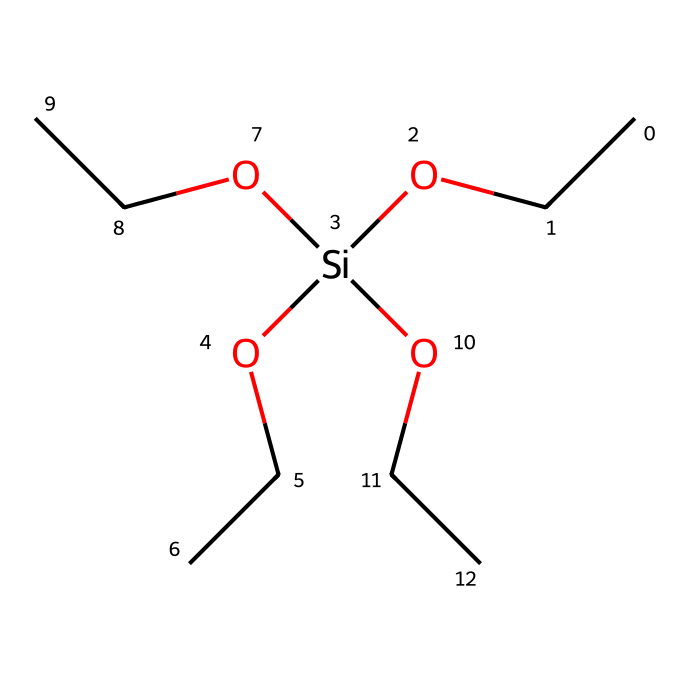What is the name of this chemical? The SMILES representation corresponds to an alkoxysilane, which is specifically known as triethoxysilane. The presence of three ethoxy (OCC) groups connected to the silicon atom indicates its classification as an alkoxysilane.
Answer: triethoxysilane How many ethoxy groups are attached to the silicon atom? In the provided SMILES representation, the silicon atom is connected to three ethoxy groups, as indicated by the three instances of "OCC". This directly corresponds to the definition of triethoxysilane.
Answer: three What is the central atom in the chemical structure? The central atom in the SMILES representation is silicon, denoted by "Si". It is the main atom to which all other groups (the ethoxy groups and hydroxyl) are connected.
Answer: silicon What type of bonds connect the ethoxy groups to the silicon? The ethoxy groups are connected to the silicon atom through covalent bonds. Covalent bonding occurs between silicon and the oxygen atoms of the ethoxy groups, allowing them to share electrons.
Answer: covalent How many oxygen atoms are present in the chemical? Upon analyzing the SMILES representation, it can be seen that there are four oxygen atoms: one from the silicon atom's oxygen substituent and three from each ethoxy group. This totals to four oxygen atoms in the structure.
Answer: four What functional groups are present in this chemical? This chemical contains two types of functional groups: alkoxy groups (the three ethoxy groups) and hydroxyl groups (the single hydroxyl connected to silicon). These contribute to its properties as an alkoxysilane.
Answer: alkoxy and hydroxyl 